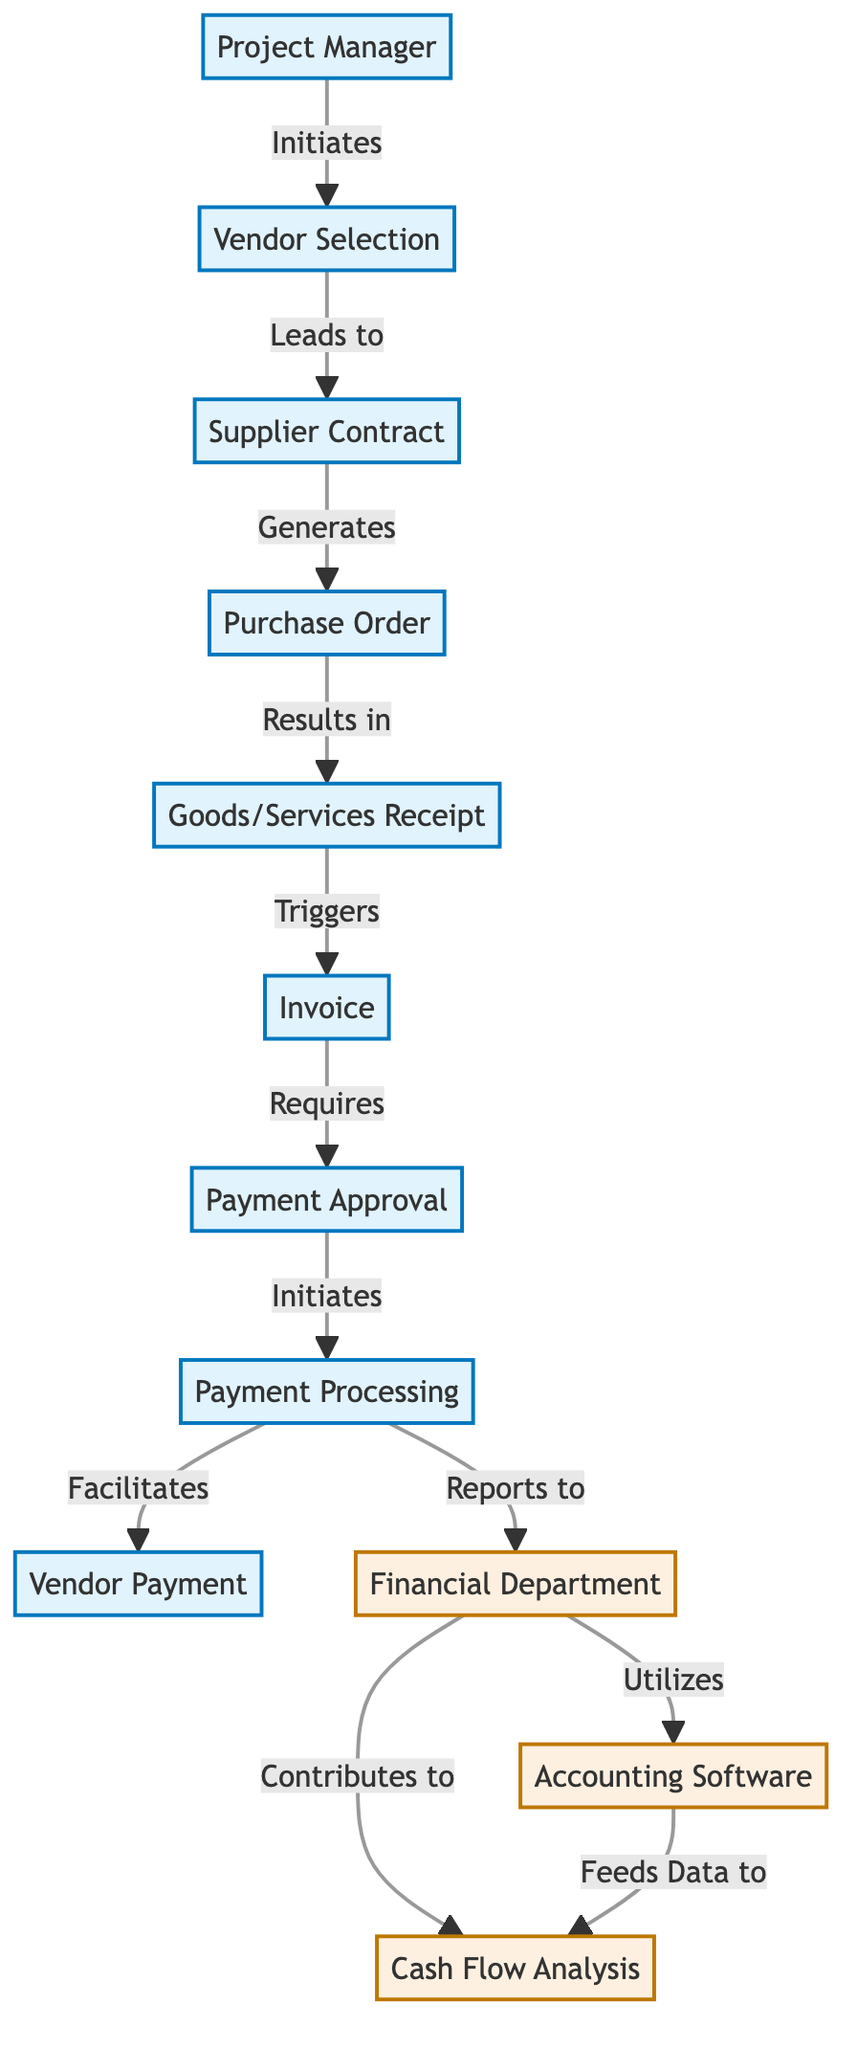What is the starting point of the process? The starting point is the "Project Manager" node, which initiates the vendor selection process.
Answer: Project Manager How many nodes are in the diagram? There are 12 nodes represented in the diagram. Each entity involved in the payment process and cash flow management is depicted as a node.
Answer: 12 What action leads from "Supplier Contract" to "Purchase Order"? The action that leads from the "Supplier Contract" to the "Purchase Order" is labeled as "Generates".
Answer: Generates What initiates the "Payment Processing"? The "Payment Processing" is initiated by the "Payment Approval" node, which comes after the invoice stage.
Answer: Payment Approval Which node does the "Financial Department" report to? The "Financial Department" reports to the "Payment Processing" node as indicated in the diagram.
Answer: Payment Processing What contributes to the "Cash Flow Analysis"? The "Financial Department" contributes to the "Cash Flow Analysis", indicating its role in assessing financial health.
Answer: Financial Department What is required before the invoice can be processed? The invoice requires "Payment Approval" before it can proceed to the payment processing stage.
Answer: Payment Approval How does "Accounting Software" relate to "Cash Flow Analysis"? The "Accounting Software" feeds data to the "Cash Flow Analysis", allowing financial data to be utilized effectively.
Answer: Feeds Data to Which node follows "Goods/Services Receipt"? After the "Goods/Services Receipt", the next node is the "Invoice", which is triggered by the receipt of goods or services.
Answer: Invoice What is the final output related to the cash flow in the process? The final output related to cash flow is the "Cash Flow Analysis", which summarizes the financial data processed through the system.
Answer: Cash Flow Analysis 